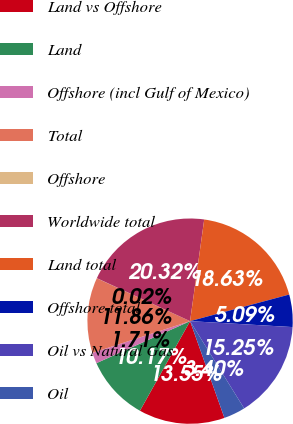Convert chart. <chart><loc_0><loc_0><loc_500><loc_500><pie_chart><fcel>Land vs Offshore<fcel>Land<fcel>Offshore (incl Gulf of Mexico)<fcel>Total<fcel>Offshore<fcel>Worldwide total<fcel>Land total<fcel>Offshore total<fcel>Oil vs Natural Gas<fcel>Oil<nl><fcel>13.55%<fcel>10.17%<fcel>1.71%<fcel>11.86%<fcel>0.02%<fcel>20.32%<fcel>18.63%<fcel>5.09%<fcel>15.25%<fcel>3.4%<nl></chart> 